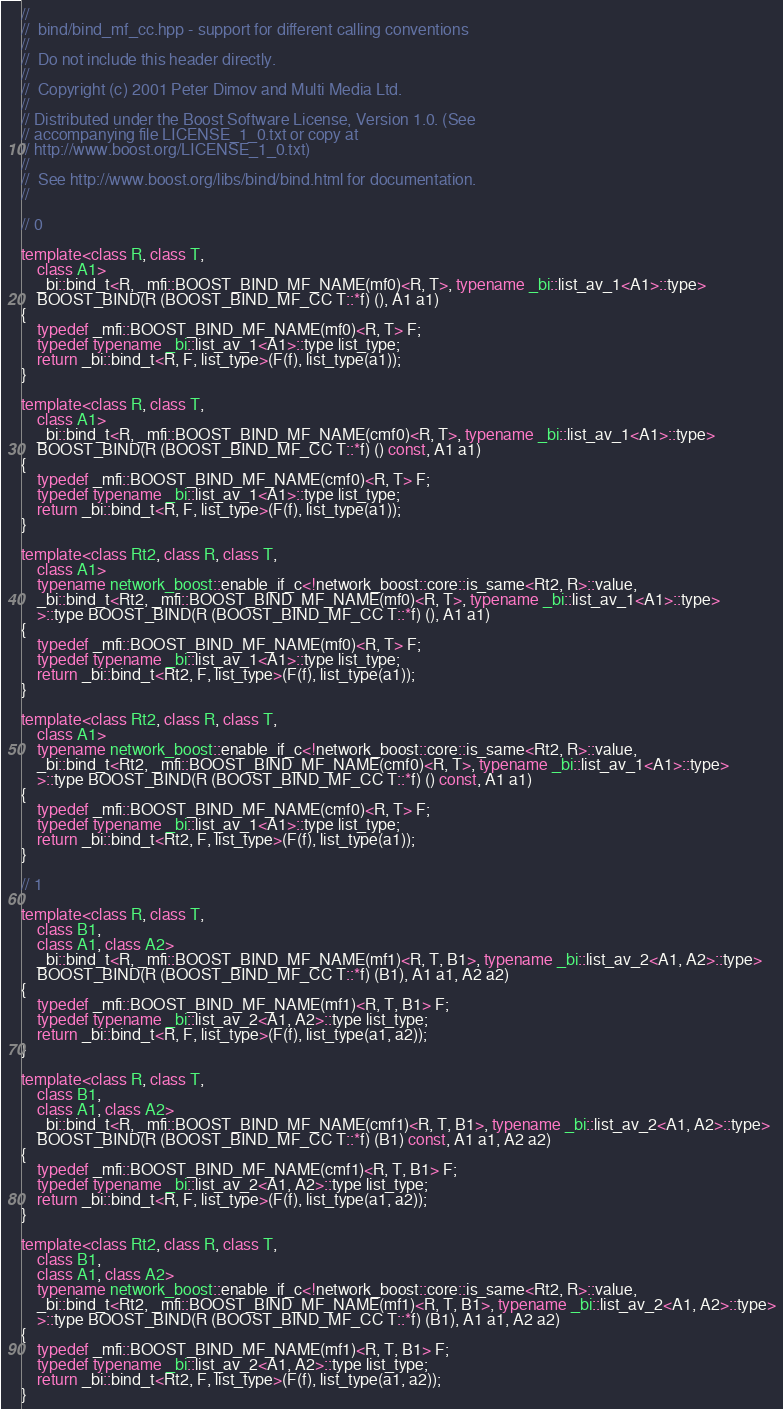<code> <loc_0><loc_0><loc_500><loc_500><_C++_>//
//  bind/bind_mf_cc.hpp - support for different calling conventions
//
//  Do not include this header directly.
//
//  Copyright (c) 2001 Peter Dimov and Multi Media Ltd.
//
// Distributed under the Boost Software License, Version 1.0. (See
// accompanying file LICENSE_1_0.txt or copy at
// http://www.boost.org/LICENSE_1_0.txt)
//
//  See http://www.boost.org/libs/bind/bind.html for documentation.
//

// 0

template<class R, class T,
    class A1>
    _bi::bind_t<R, _mfi::BOOST_BIND_MF_NAME(mf0)<R, T>, typename _bi::list_av_1<A1>::type>
    BOOST_BIND(R (BOOST_BIND_MF_CC T::*f) (), A1 a1)
{
    typedef _mfi::BOOST_BIND_MF_NAME(mf0)<R, T> F;
    typedef typename _bi::list_av_1<A1>::type list_type;
    return _bi::bind_t<R, F, list_type>(F(f), list_type(a1));
}

template<class R, class T,
    class A1>
    _bi::bind_t<R, _mfi::BOOST_BIND_MF_NAME(cmf0)<R, T>, typename _bi::list_av_1<A1>::type>
    BOOST_BIND(R (BOOST_BIND_MF_CC T::*f) () const, A1 a1)
{
    typedef _mfi::BOOST_BIND_MF_NAME(cmf0)<R, T> F;
    typedef typename _bi::list_av_1<A1>::type list_type;
    return _bi::bind_t<R, F, list_type>(F(f), list_type(a1));
}

template<class Rt2, class R, class T,
    class A1>
    typename network_boost::enable_if_c<!network_boost::core::is_same<Rt2, R>::value,
    _bi::bind_t<Rt2, _mfi::BOOST_BIND_MF_NAME(mf0)<R, T>, typename _bi::list_av_1<A1>::type>
    >::type BOOST_BIND(R (BOOST_BIND_MF_CC T::*f) (), A1 a1)
{
    typedef _mfi::BOOST_BIND_MF_NAME(mf0)<R, T> F;
    typedef typename _bi::list_av_1<A1>::type list_type;
    return _bi::bind_t<Rt2, F, list_type>(F(f), list_type(a1));
}

template<class Rt2, class R, class T,
    class A1>
    typename network_boost::enable_if_c<!network_boost::core::is_same<Rt2, R>::value,
    _bi::bind_t<Rt2, _mfi::BOOST_BIND_MF_NAME(cmf0)<R, T>, typename _bi::list_av_1<A1>::type>
    >::type BOOST_BIND(R (BOOST_BIND_MF_CC T::*f) () const, A1 a1)
{
    typedef _mfi::BOOST_BIND_MF_NAME(cmf0)<R, T> F;
    typedef typename _bi::list_av_1<A1>::type list_type;
    return _bi::bind_t<Rt2, F, list_type>(F(f), list_type(a1));
}

// 1

template<class R, class T,
    class B1,
    class A1, class A2>
    _bi::bind_t<R, _mfi::BOOST_BIND_MF_NAME(mf1)<R, T, B1>, typename _bi::list_av_2<A1, A2>::type>
    BOOST_BIND(R (BOOST_BIND_MF_CC T::*f) (B1), A1 a1, A2 a2)
{
    typedef _mfi::BOOST_BIND_MF_NAME(mf1)<R, T, B1> F;
    typedef typename _bi::list_av_2<A1, A2>::type list_type;
    return _bi::bind_t<R, F, list_type>(F(f), list_type(a1, a2));
}

template<class R, class T,
    class B1,
    class A1, class A2>
    _bi::bind_t<R, _mfi::BOOST_BIND_MF_NAME(cmf1)<R, T, B1>, typename _bi::list_av_2<A1, A2>::type>
    BOOST_BIND(R (BOOST_BIND_MF_CC T::*f) (B1) const, A1 a1, A2 a2)
{
    typedef _mfi::BOOST_BIND_MF_NAME(cmf1)<R, T, B1> F;
    typedef typename _bi::list_av_2<A1, A2>::type list_type;
    return _bi::bind_t<R, F, list_type>(F(f), list_type(a1, a2));
}

template<class Rt2, class R, class T,
    class B1,
    class A1, class A2>
    typename network_boost::enable_if_c<!network_boost::core::is_same<Rt2, R>::value,
    _bi::bind_t<Rt2, _mfi::BOOST_BIND_MF_NAME(mf1)<R, T, B1>, typename _bi::list_av_2<A1, A2>::type>
    >::type BOOST_BIND(R (BOOST_BIND_MF_CC T::*f) (B1), A1 a1, A2 a2)
{
    typedef _mfi::BOOST_BIND_MF_NAME(mf1)<R, T, B1> F;
    typedef typename _bi::list_av_2<A1, A2>::type list_type;
    return _bi::bind_t<Rt2, F, list_type>(F(f), list_type(a1, a2));
}
</code> 